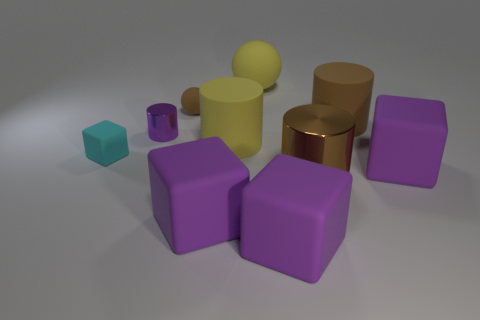There is a large ball that is made of the same material as the small brown sphere; what is its color? In the image, the large ball appears to have a yellow hue, similar to the tone observed on the small brown sphere when taking lighting and shadows into account. The similarity in material suggests that the coloration would be consistent, hence one can infer that under identical lighting conditions, both objects would exhibit a comparable brown shade. 